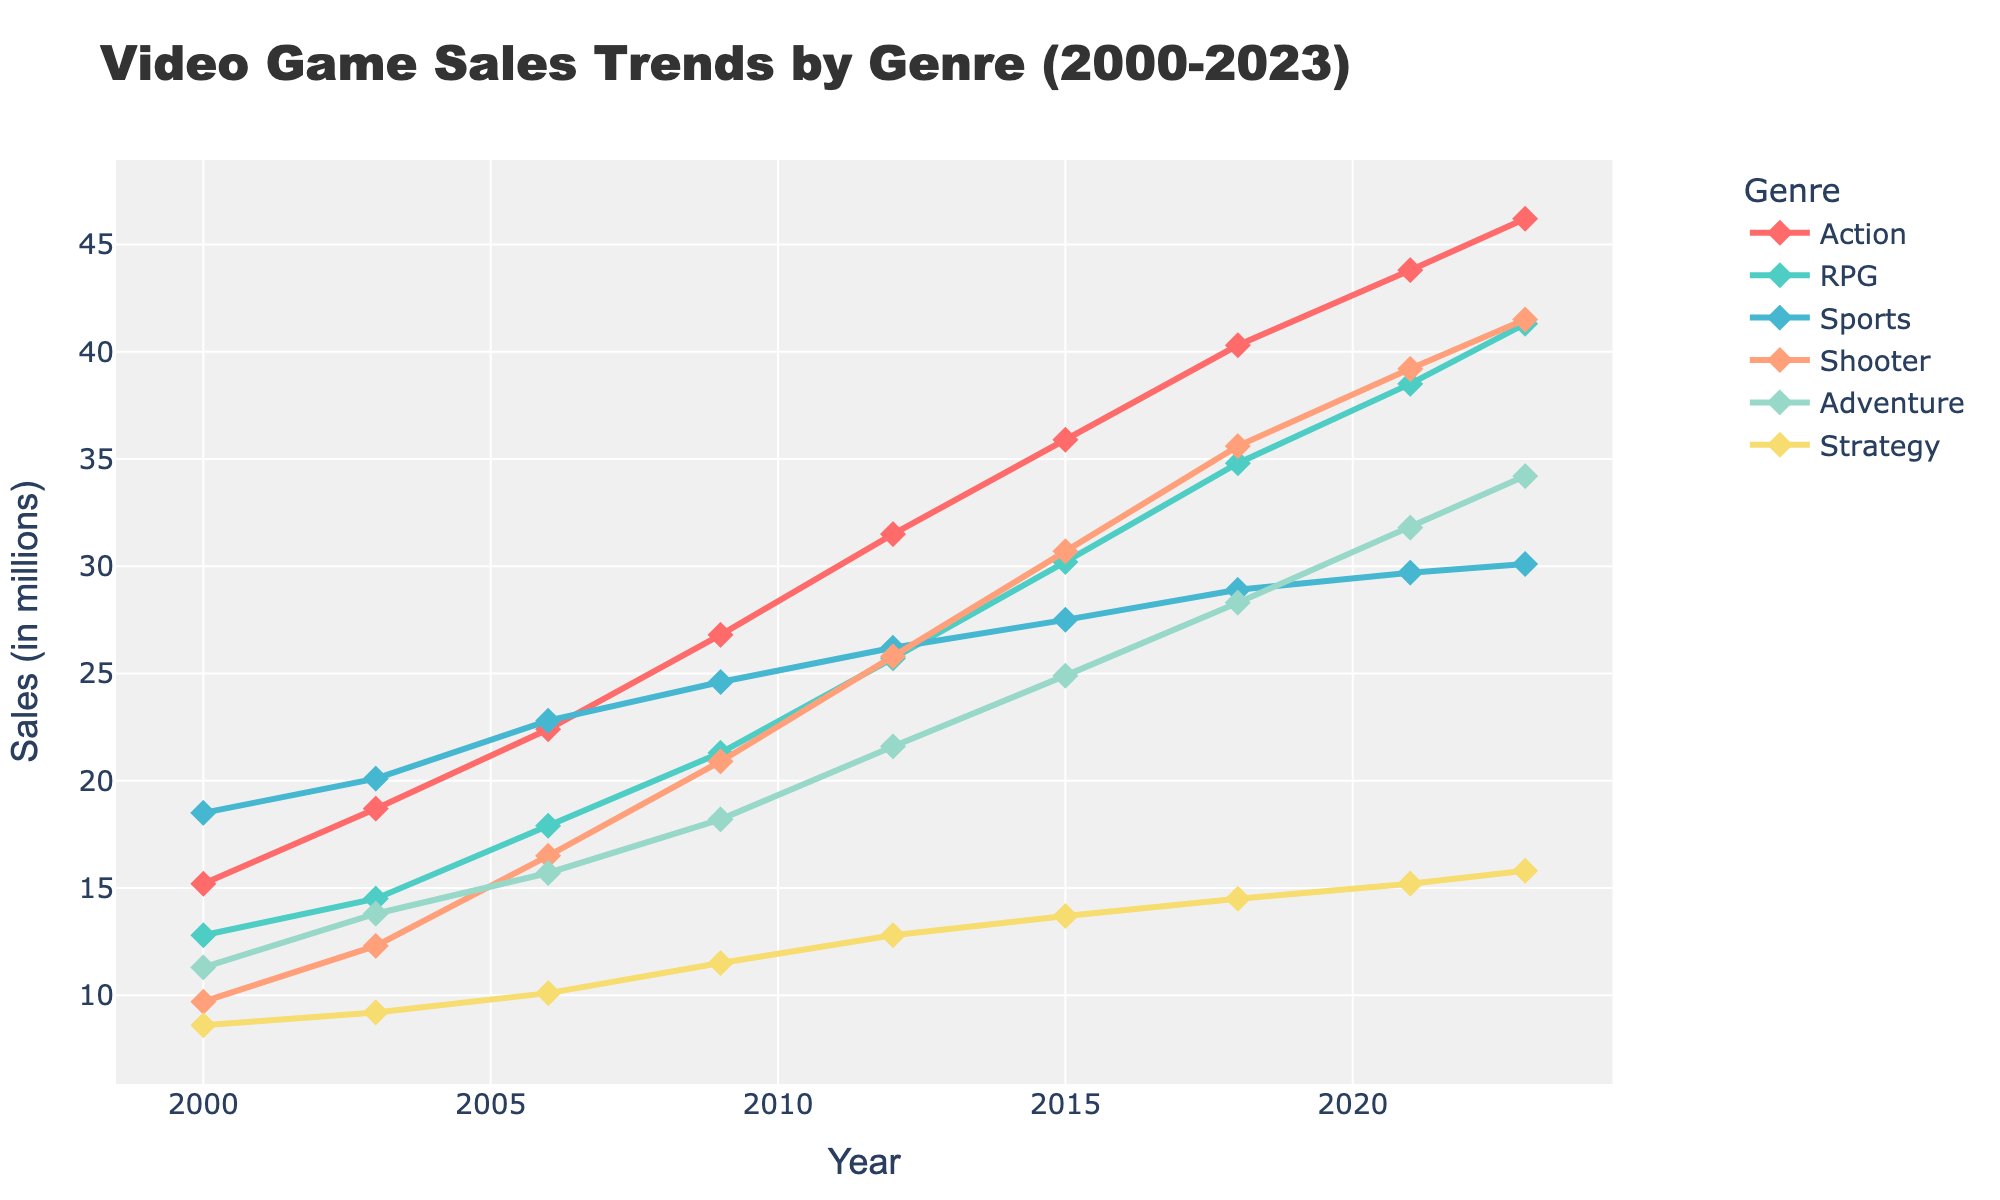How has the sales trend for Action games changed from 2000 to 2023? From the figure, notice the consistent trendline for Action game sales. In 2000, the sales were 15.2 million, and by 2023, they had risen to 46.2 million. This shows a steady increase over the years.
Answer: Steadily increased Which genre displayed the highest sales in 2000? Examine the topmost point in the 2000 data points on the chart. You will see that Sports games had the highest sales at 18.5 million.
Answer: Sports Between 2003 and 2009, which genre saw the largest absolute increase in sales? Note down the sales figures for each genre in 2003 and 2009. Calculate the difference: Action (26.8 - 18.7 = 8.1), RPG (21.3 - 14.5 = 6.8), Sports (24.6 - 20.1 = 4.5), Shooter (20.9 - 12.3 = 8.6), Adventure (18.2 - 13.8 = 4.4), Strategy (11.5 - 9.2 = 2.3). Shooter games saw the largest increase (8.6 million).
Answer: Shooter What was the average sales figure for RPG games from 2000 to 2023? Sum the sales numbers for RPG games over the years (12.8 + 14.5 + 17.9 + 21.3 + 25.7 + 30.2 + 34.8 + 38.5 + 41.3 = 237). There are 9 years considered, so divide the total by 9 (237 / 9 ≈ 26.3).
Answer: 26.3 million Which genre had the smallest percent increase in sales from 2000 to 2023? Calculate the percent increase for each genre using the formula ((Sales in 2023 - Sales in 2000) / Sales in 2000 * 100). Action ((46.2 - 15.2) / 15.2 * 100 ≈ 204%), RPG ((41.3 - 12.8) / 12.8 * 100 ≈ 223%), Sports ((30.1 - 18.5) / 18.5 * 100 ≈ 63%), Shooter ((41.5 - 9.7) / 9.7 * 328%), Adventure ((34.2 - 11.3) / 11.3 * 100 ≈ 202%), Strategy ((15.8 - 8.6) / 8.6 * 100 ≈ 84%). Sports had the smallest percent increase.
Answer: Sports By how much did sales of Strategy games grow from 2006 to 2023? Note the sales figures of Strategy games for the years 2006 and 2023. Subtract to find the growth: 15.8 million in 2023 - 10.1 million in 2006 = 5.7 million.
Answer: 5.7 million In which year did Shooter games surpass RPG games in sales? Observe the trends for Shooter and RPG lines. Shooter games first surpass RPG games between 2006 (Shooter: 16.5, RPG: 17.9) and 2009, and the line for Shooter is above RPG in 2009 and thereafter.
Answer: 2009 Which genre shows the most consistent increase over the years? Compare the trend lines of all genres. The Action genre demonstrates the most consistent upward trend with no dips, increasing steadily every considered year.
Answer: Action Average sales for Sports and Adventure genres in 2021? Sum the sales for Sports (29.7) and Adventure (31.8), then divide by 2. (29.7 + 31.8) / 2 = 30.75.
Answer: 30.75 million 